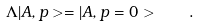<formula> <loc_0><loc_0><loc_500><loc_500>\Lambda | A , { p } > = | A , { p } = 0 > \quad .</formula> 